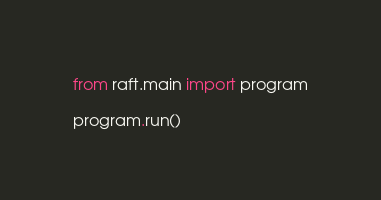<code> <loc_0><loc_0><loc_500><loc_500><_Python_>from raft.main import program

program.run()
</code> 